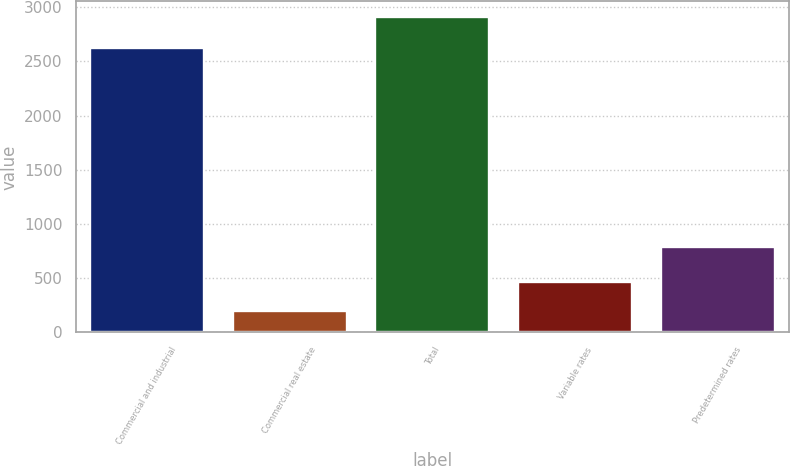Convert chart to OTSL. <chart><loc_0><loc_0><loc_500><loc_500><bar_chart><fcel>Commercial and industrial<fcel>Commercial real estate<fcel>Total<fcel>Variable rates<fcel>Predetermined rates<nl><fcel>2627.2<fcel>197.7<fcel>2908.1<fcel>468.74<fcel>790<nl></chart> 